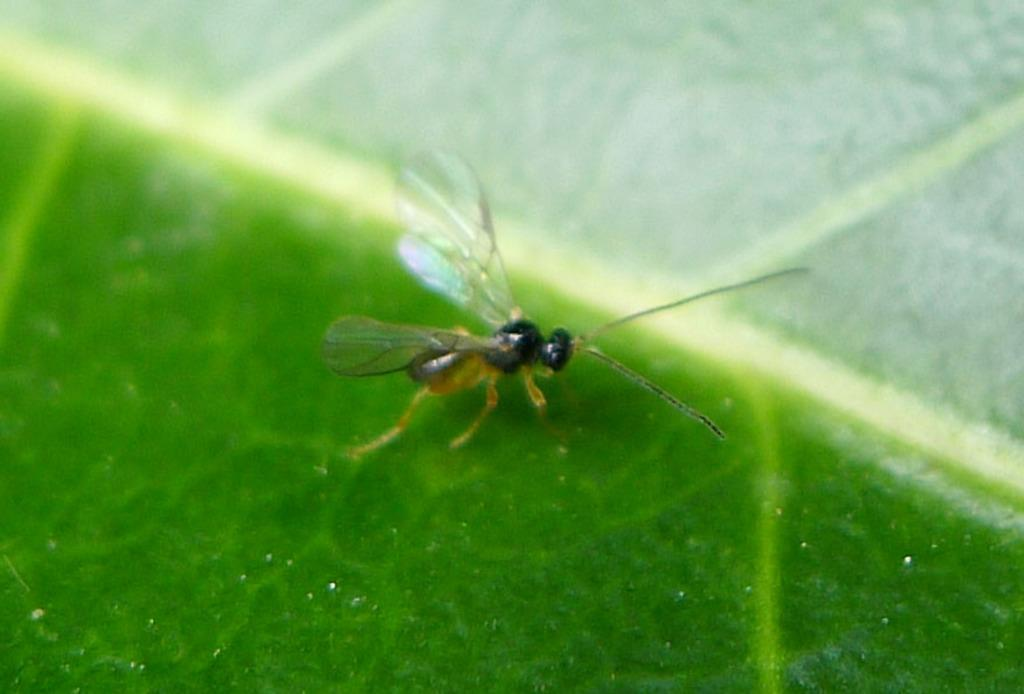What type of creature is in the image? There is an insect in the image. Where is the insect located? The insect is on a leaf. Can you describe the position of the insect in the image? The insect is in the center of the image. What type of job does the secretary have in the image? There is no secretary present in the image; it features an insect on a leaf. What type of advice does the coach give to the insect in the image? There is no coach present in the image, and insects do not receive advice from coaches. 